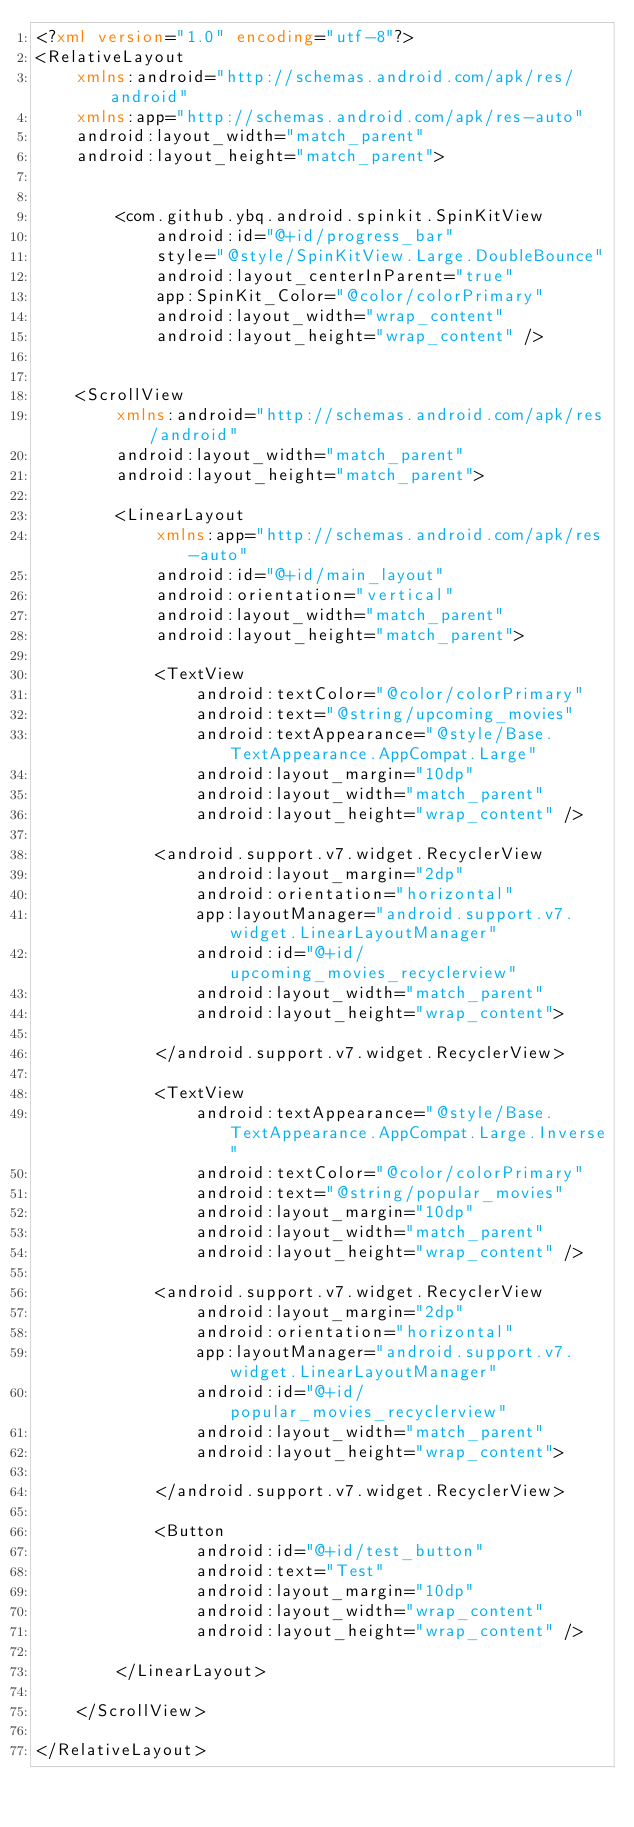Convert code to text. <code><loc_0><loc_0><loc_500><loc_500><_XML_><?xml version="1.0" encoding="utf-8"?>
<RelativeLayout
    xmlns:android="http://schemas.android.com/apk/res/android"
    xmlns:app="http://schemas.android.com/apk/res-auto"
    android:layout_width="match_parent"
    android:layout_height="match_parent">


        <com.github.ybq.android.spinkit.SpinKitView
            android:id="@+id/progress_bar"
            style="@style/SpinKitView.Large.DoubleBounce"
            android:layout_centerInParent="true"
            app:SpinKit_Color="@color/colorPrimary"
            android:layout_width="wrap_content"
            android:layout_height="wrap_content" />


    <ScrollView
        xmlns:android="http://schemas.android.com/apk/res/android"
        android:layout_width="match_parent"
        android:layout_height="match_parent">

        <LinearLayout
            xmlns:app="http://schemas.android.com/apk/res-auto"
            android:id="@+id/main_layout"
            android:orientation="vertical"
            android:layout_width="match_parent"
            android:layout_height="match_parent">

            <TextView
                android:textColor="@color/colorPrimary"
                android:text="@string/upcoming_movies"
                android:textAppearance="@style/Base.TextAppearance.AppCompat.Large"
                android:layout_margin="10dp"
                android:layout_width="match_parent"
                android:layout_height="wrap_content" />

            <android.support.v7.widget.RecyclerView
                android:layout_margin="2dp"
                android:orientation="horizontal"
                app:layoutManager="android.support.v7.widget.LinearLayoutManager"
                android:id="@+id/upcoming_movies_recyclerview"
                android:layout_width="match_parent"
                android:layout_height="wrap_content">

            </android.support.v7.widget.RecyclerView>

            <TextView
                android:textAppearance="@style/Base.TextAppearance.AppCompat.Large.Inverse"
                android:textColor="@color/colorPrimary"
                android:text="@string/popular_movies"
                android:layout_margin="10dp"
                android:layout_width="match_parent"
                android:layout_height="wrap_content" />

            <android.support.v7.widget.RecyclerView
                android:layout_margin="2dp"
                android:orientation="horizontal"
                app:layoutManager="android.support.v7.widget.LinearLayoutManager"
                android:id="@+id/popular_movies_recyclerview"
                android:layout_width="match_parent"
                android:layout_height="wrap_content">

            </android.support.v7.widget.RecyclerView>

            <Button
                android:id="@+id/test_button"
                android:text="Test"
                android:layout_margin="10dp"
                android:layout_width="wrap_content"
                android:layout_height="wrap_content" />

        </LinearLayout>

    </ScrollView>

</RelativeLayout>

</code> 